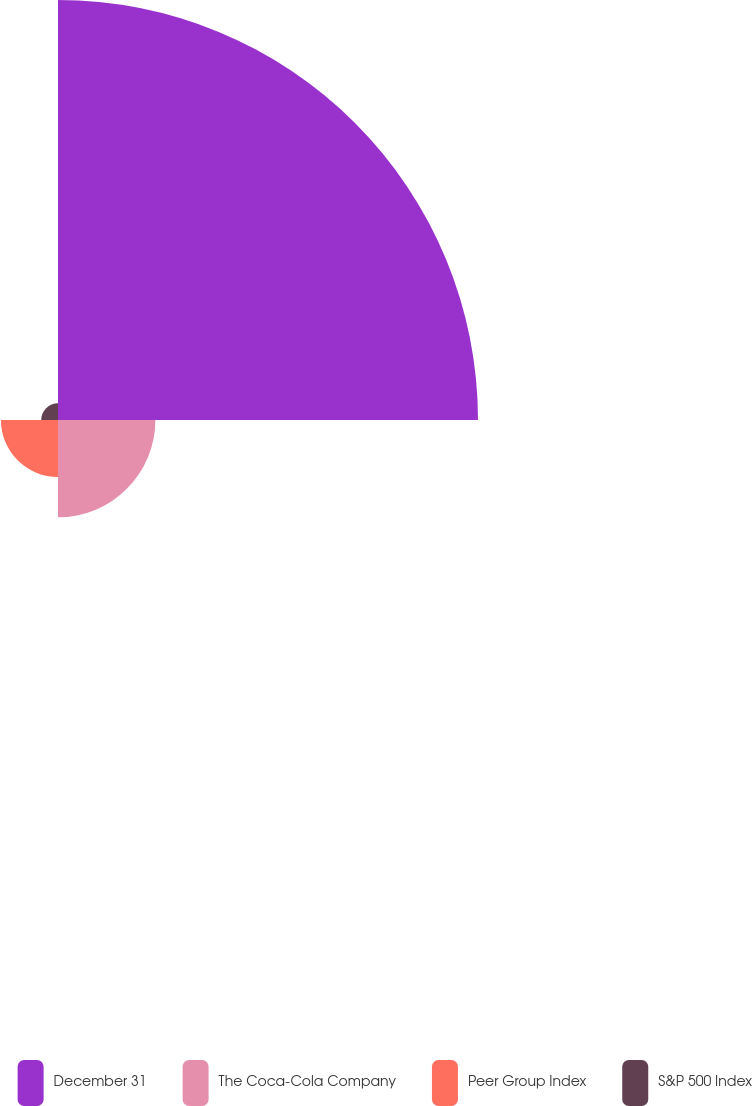<chart> <loc_0><loc_0><loc_500><loc_500><pie_chart><fcel>December 31<fcel>The Coca-Cola Company<fcel>Peer Group Index<fcel>S&P 500 Index<nl><fcel>71.05%<fcel>16.47%<fcel>9.65%<fcel>2.83%<nl></chart> 